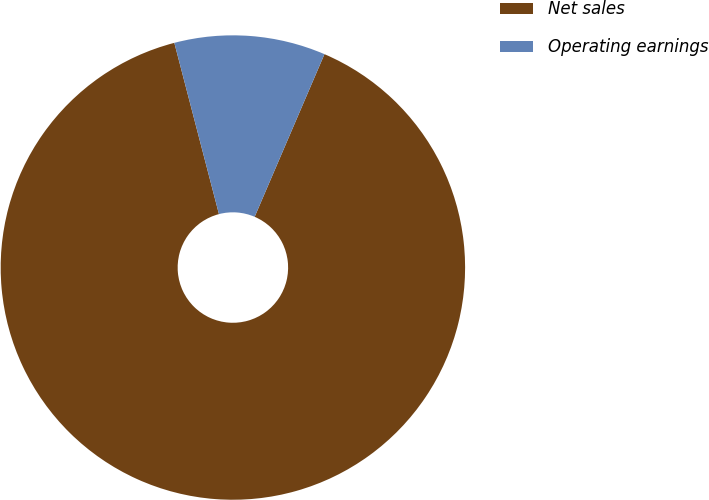Convert chart. <chart><loc_0><loc_0><loc_500><loc_500><pie_chart><fcel>Net sales<fcel>Operating earnings<nl><fcel>89.49%<fcel>10.51%<nl></chart> 